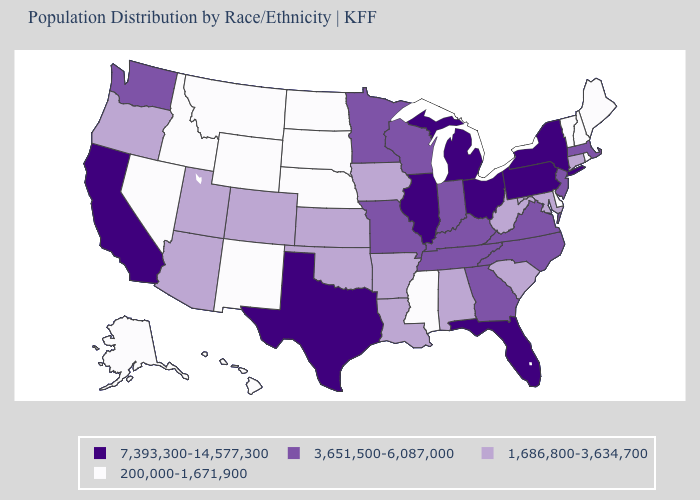Name the states that have a value in the range 7,393,300-14,577,300?
Give a very brief answer. California, Florida, Illinois, Michigan, New York, Ohio, Pennsylvania, Texas. What is the value of New Jersey?
Give a very brief answer. 3,651,500-6,087,000. What is the value of Idaho?
Keep it brief. 200,000-1,671,900. Does the map have missing data?
Keep it brief. No. What is the value of Virginia?
Give a very brief answer. 3,651,500-6,087,000. Does Mississippi have the highest value in the South?
Give a very brief answer. No. What is the value of Kansas?
Give a very brief answer. 1,686,800-3,634,700. Among the states that border Connecticut , does Massachusetts have the lowest value?
Short answer required. No. Does New Mexico have the lowest value in the USA?
Keep it brief. Yes. Does the first symbol in the legend represent the smallest category?
Short answer required. No. Does the first symbol in the legend represent the smallest category?
Be succinct. No. Among the states that border South Dakota , which have the lowest value?
Keep it brief. Montana, Nebraska, North Dakota, Wyoming. What is the highest value in the West ?
Be succinct. 7,393,300-14,577,300. What is the highest value in the Northeast ?
Be succinct. 7,393,300-14,577,300. Name the states that have a value in the range 1,686,800-3,634,700?
Be succinct. Alabama, Arizona, Arkansas, Colorado, Connecticut, Iowa, Kansas, Louisiana, Maryland, Oklahoma, Oregon, South Carolina, Utah, West Virginia. 